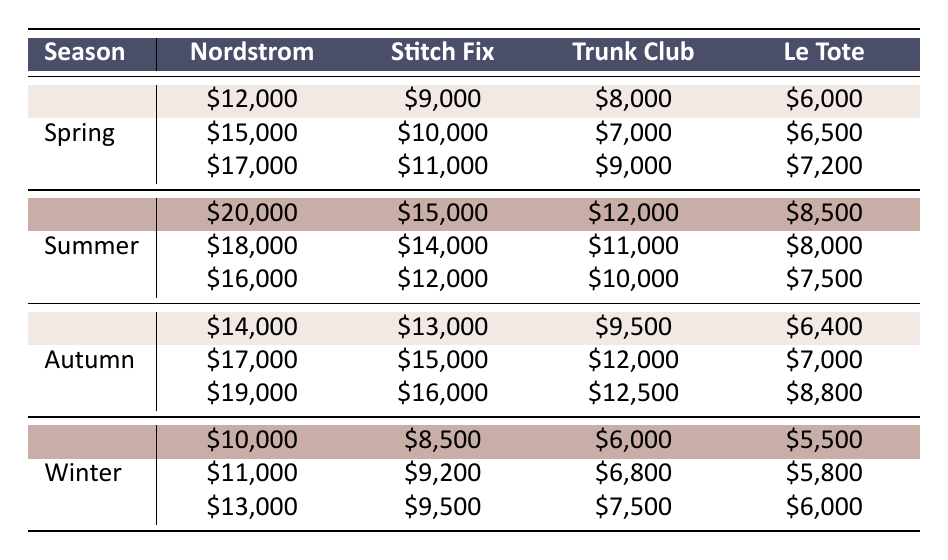What was the total revenue from Nordstrom in Spring? To find the total revenue from Nordstrom in Spring, we sum the revenues for April, May, and June: 12000 + 15000 + 17000 = 44000.
Answer: 44000 Which month had the highest revenue for Stitch Fix in Summer? We check the revenue for Stitch Fix in July (15000), August (14000), and September (12000). July has the highest revenue of 15000.
Answer: July Is the revenue for Le Tote in December greater than in other months of Winter? Le Tote revenue in Winter months are 5500, 5800, and 6000 for January, February, and March respectively. December's revenue is 8800, which is greater than all of them.
Answer: Yes What is the average revenue from Trunk Club in Autumn? We find the Autumn revenues for Trunk Club are 9500, 12000, and 12500 for October, November, and December. The average is calculated as (9500 + 12000 + 12500) / 3 = 11000.
Answer: 11000 How much more revenue did Nordstrom generate in Winter compared to Summer? The total revenue from Nordstrom in Winter is 10000 + 11000 + 13000 = 34000. In Summer, it is 20000 + 18000 + 16000 = 54000. We find the difference is 34000 - 54000 = -20000, indicating Nordstrom generated 20000 less in Winter.
Answer: 20000 less What is the total revenue for Le Tote in the entire year? We calculate Le Tote's total revenue from all months: 6000 + 6500 + 7200 + 8500 + 8000 + 7500 + 6400 + 7000 + 8800 + 5500 + 5800 + 6000 =  71000.
Answer: 71000 Did Trunk Club's revenue increase each month in Spring? In Spring, Trunk Club revenues for April (8000), May (7000), and June (9000) show a decrease from April to May, hence it did not increase every month.
Answer: No Which service had the highest monthly revenue in Autumn? We compare the monthly revenues in Autumn: Nordstrom (19000), Stitch Fix (16000), Trunk Club (12500), and Le Tote (8800). Nordstrom's revenue in December is the highest at 19000.
Answer: Nordstrom in December 